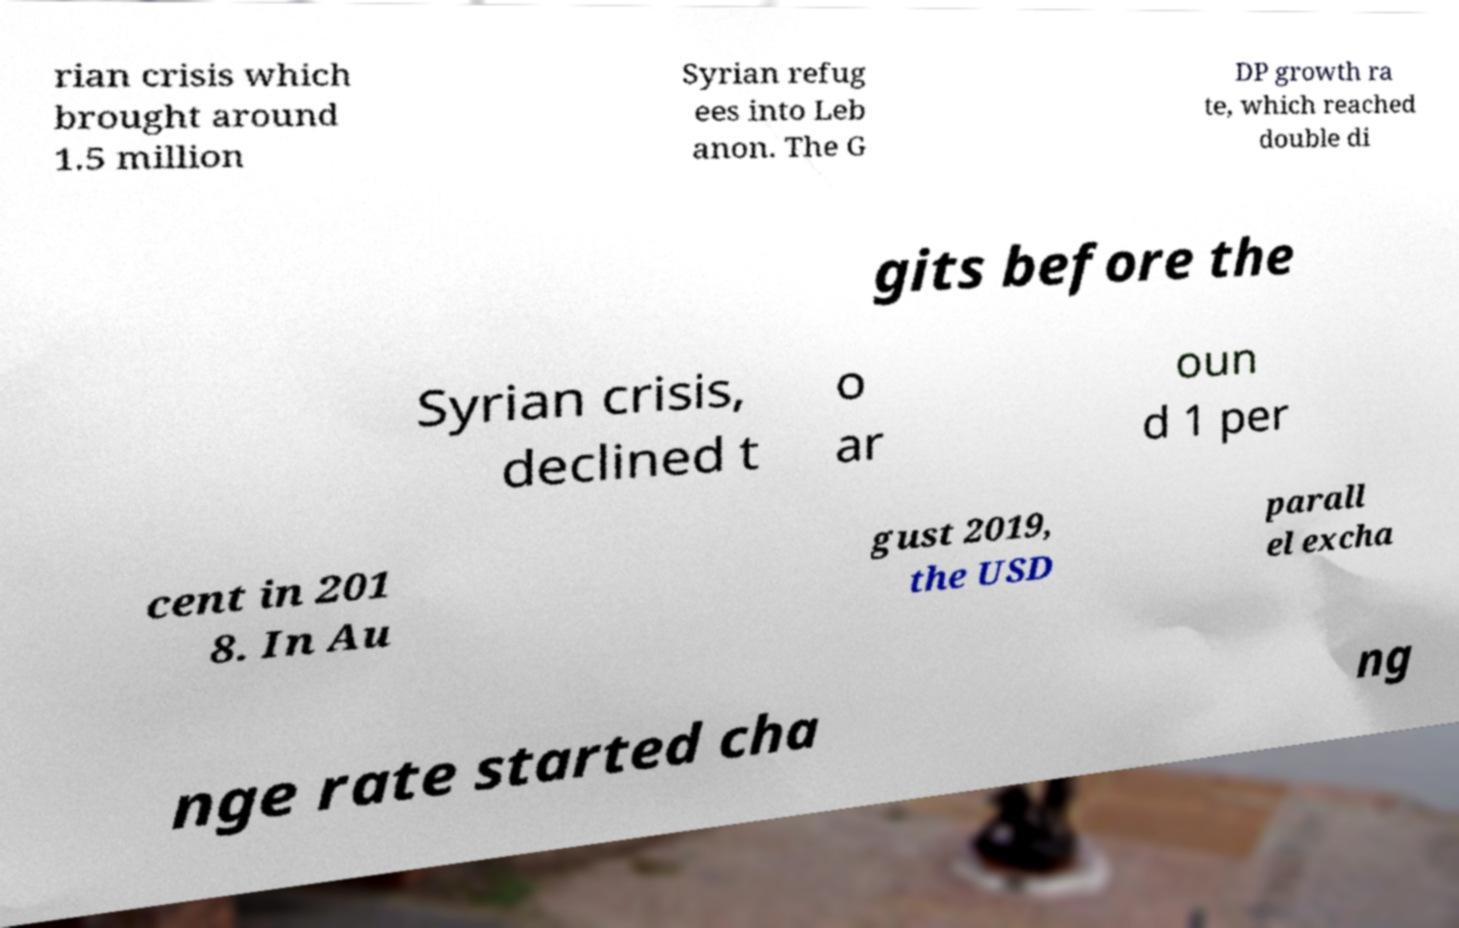Could you extract and type out the text from this image? rian crisis which brought around 1.5 million Syrian refug ees into Leb anon. The G DP growth ra te, which reached double di gits before the Syrian crisis, declined t o ar oun d 1 per cent in 201 8. In Au gust 2019, the USD parall el excha nge rate started cha ng 